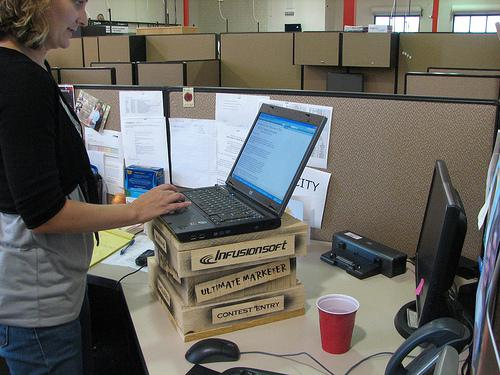Question: what is the woman doing?
Choices:
A. Playing on laptop.
B. Using typewriter.
C. Dialing her phone.
D. Connecting a PC.
Answer with the letter. Answer: A Question: how many cups?
Choices:
A. Two.
B. Three.
C. One.
D. Five.
Answer with the letter. Answer: C Question: where is the woman?
Choices:
A. In an elevator.
B. In a hallway.
C. In a lobby.
D. In a cubicle.
Answer with the letter. Answer: D 